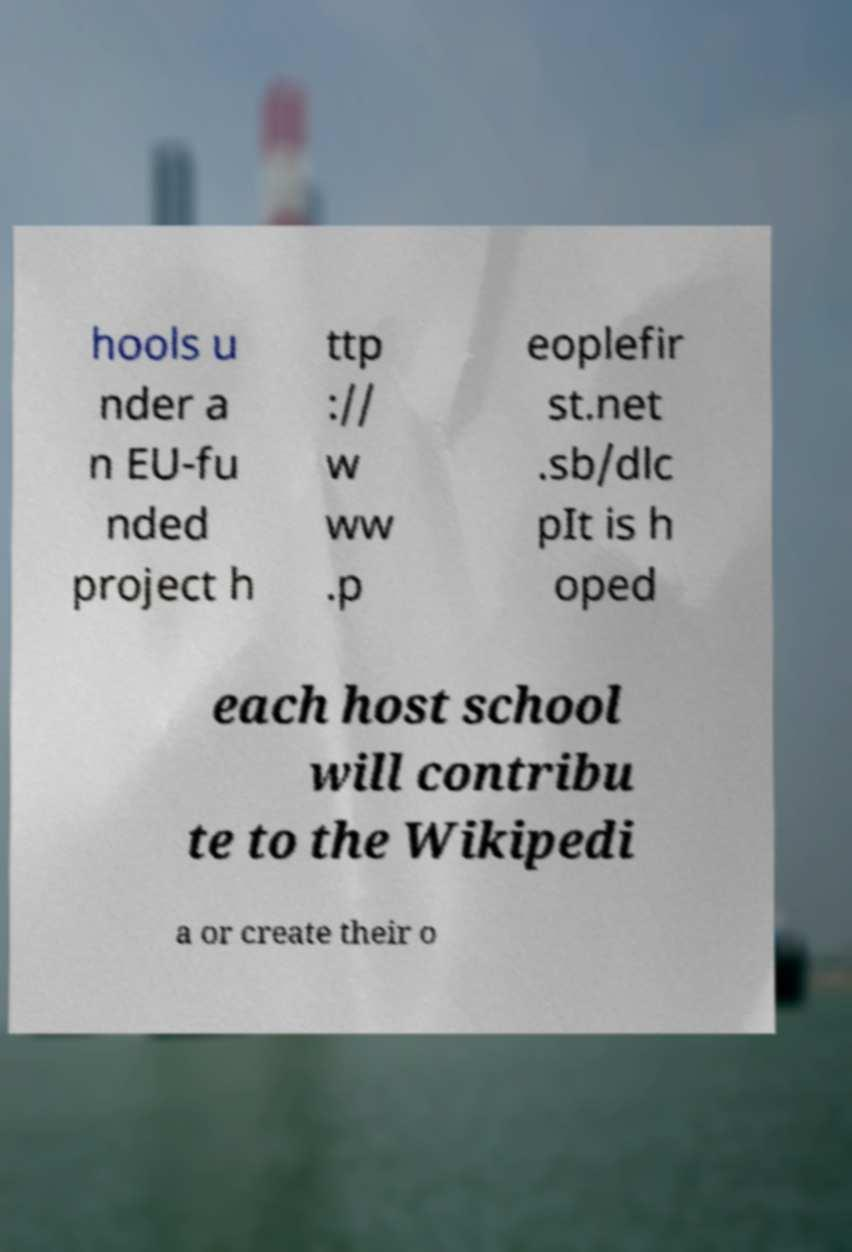What messages or text are displayed in this image? I need them in a readable, typed format. hools u nder a n EU-fu nded project h ttp :// w ww .p eoplefir st.net .sb/dlc pIt is h oped each host school will contribu te to the Wikipedi a or create their o 